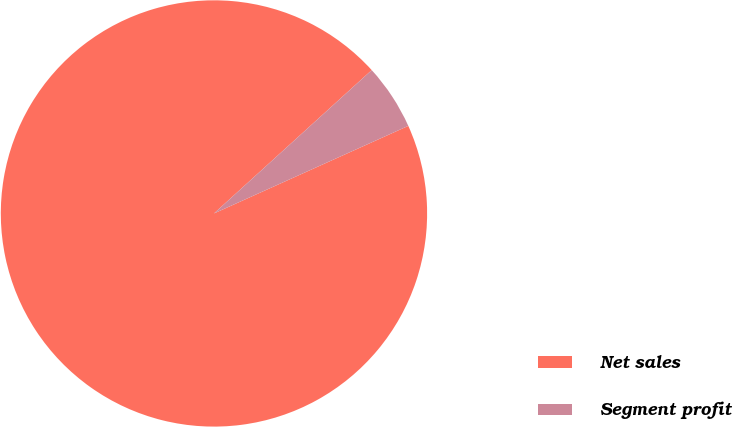Convert chart to OTSL. <chart><loc_0><loc_0><loc_500><loc_500><pie_chart><fcel>Net sales<fcel>Segment profit<nl><fcel>95.0%<fcel>5.0%<nl></chart> 